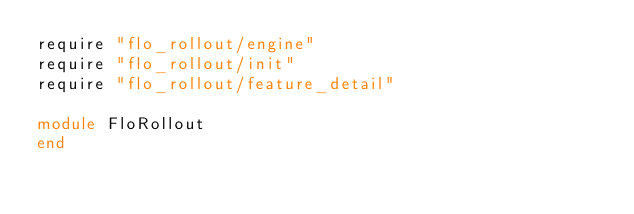Convert code to text. <code><loc_0><loc_0><loc_500><loc_500><_Ruby_>require "flo_rollout/engine"
require "flo_rollout/init"
require "flo_rollout/feature_detail"

module FloRollout
end
</code> 